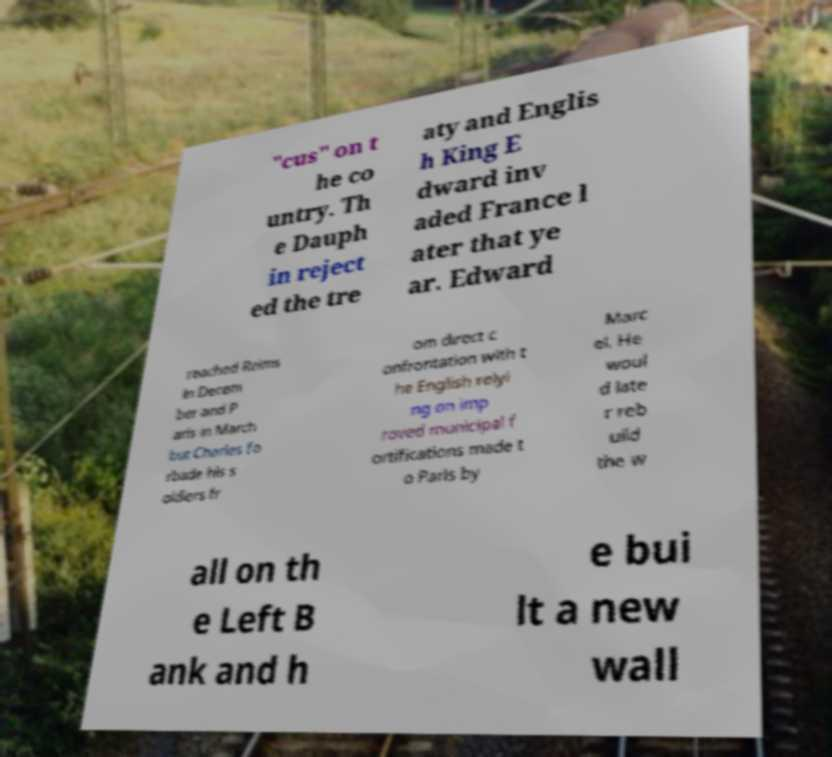What messages or text are displayed in this image? I need them in a readable, typed format. "cus" on t he co untry. Th e Dauph in reject ed the tre aty and Englis h King E dward inv aded France l ater that ye ar. Edward reached Reims in Decem ber and P aris in March but Charles fo rbade his s oldiers fr om direct c onfrontation with t he English relyi ng on imp roved municipal f ortifications made t o Paris by Marc el. He woul d late r reb uild the w all on th e Left B ank and h e bui lt a new wall 